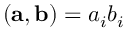Convert formula to latex. <formula><loc_0><loc_0><loc_500><loc_500>( { a } , { b } ) = a _ { i } b _ { i }</formula> 